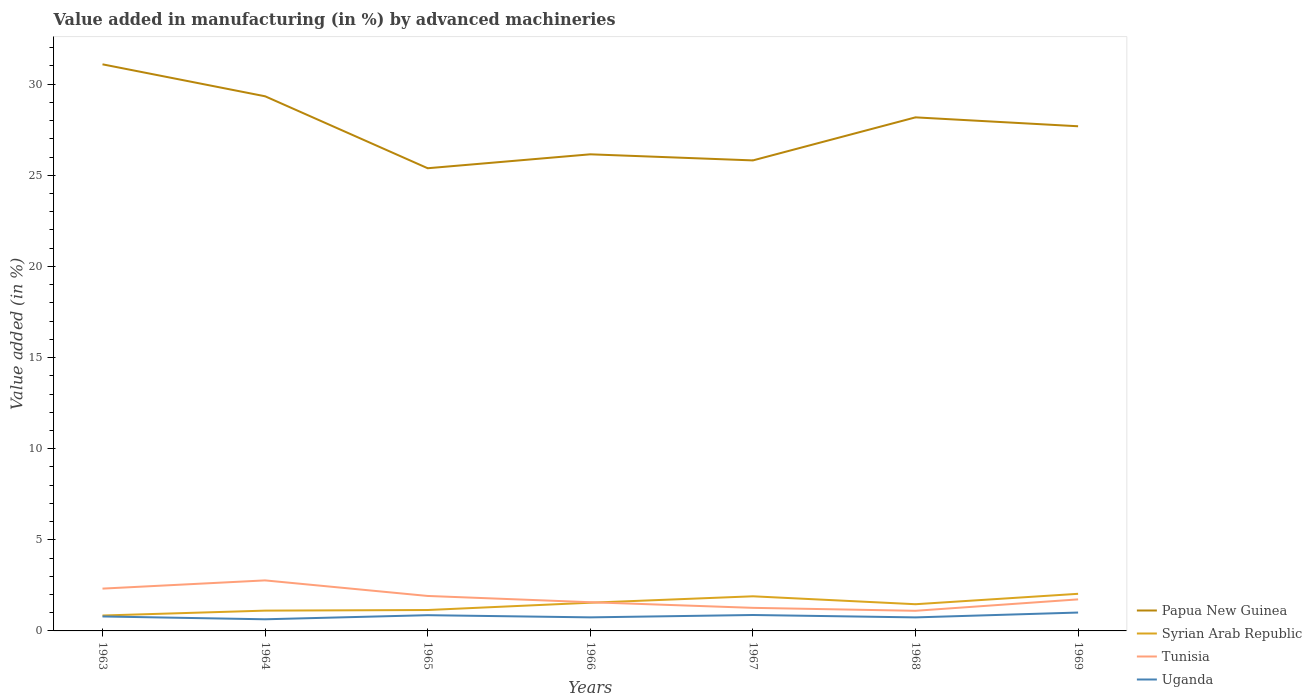How many different coloured lines are there?
Keep it short and to the point. 4. Is the number of lines equal to the number of legend labels?
Provide a succinct answer. Yes. Across all years, what is the maximum percentage of value added in manufacturing by advanced machineries in Uganda?
Keep it short and to the point. 0.64. In which year was the percentage of value added in manufacturing by advanced machineries in Uganda maximum?
Give a very brief answer. 1964. What is the total percentage of value added in manufacturing by advanced machineries in Papua New Guinea in the graph?
Keep it short and to the point. -1.54. What is the difference between the highest and the second highest percentage of value added in manufacturing by advanced machineries in Syrian Arab Republic?
Make the answer very short. 1.19. Is the percentage of value added in manufacturing by advanced machineries in Tunisia strictly greater than the percentage of value added in manufacturing by advanced machineries in Uganda over the years?
Offer a very short reply. No. How many years are there in the graph?
Keep it short and to the point. 7. What is the difference between two consecutive major ticks on the Y-axis?
Ensure brevity in your answer.  5. Does the graph contain any zero values?
Ensure brevity in your answer.  No. How are the legend labels stacked?
Ensure brevity in your answer.  Vertical. What is the title of the graph?
Ensure brevity in your answer.  Value added in manufacturing (in %) by advanced machineries. What is the label or title of the Y-axis?
Provide a succinct answer. Value added (in %). What is the Value added (in %) in Papua New Guinea in 1963?
Offer a very short reply. 31.09. What is the Value added (in %) of Syrian Arab Republic in 1963?
Give a very brief answer. 0.85. What is the Value added (in %) in Tunisia in 1963?
Make the answer very short. 2.32. What is the Value added (in %) of Uganda in 1963?
Offer a very short reply. 0.79. What is the Value added (in %) of Papua New Guinea in 1964?
Provide a succinct answer. 29.34. What is the Value added (in %) in Syrian Arab Republic in 1964?
Give a very brief answer. 1.11. What is the Value added (in %) in Tunisia in 1964?
Your answer should be very brief. 2.77. What is the Value added (in %) of Uganda in 1964?
Offer a very short reply. 0.64. What is the Value added (in %) in Papua New Guinea in 1965?
Provide a succinct answer. 25.39. What is the Value added (in %) of Syrian Arab Republic in 1965?
Ensure brevity in your answer.  1.15. What is the Value added (in %) of Tunisia in 1965?
Your answer should be very brief. 1.92. What is the Value added (in %) of Uganda in 1965?
Your response must be concise. 0.86. What is the Value added (in %) of Papua New Guinea in 1966?
Your response must be concise. 26.15. What is the Value added (in %) in Syrian Arab Republic in 1966?
Your answer should be very brief. 1.55. What is the Value added (in %) of Tunisia in 1966?
Your answer should be very brief. 1.58. What is the Value added (in %) in Uganda in 1966?
Your answer should be very brief. 0.74. What is the Value added (in %) in Papua New Guinea in 1967?
Provide a succinct answer. 25.82. What is the Value added (in %) of Syrian Arab Republic in 1967?
Offer a very short reply. 1.9. What is the Value added (in %) in Tunisia in 1967?
Offer a terse response. 1.27. What is the Value added (in %) of Uganda in 1967?
Make the answer very short. 0.87. What is the Value added (in %) in Papua New Guinea in 1968?
Your response must be concise. 28.18. What is the Value added (in %) of Syrian Arab Republic in 1968?
Provide a succinct answer. 1.46. What is the Value added (in %) in Tunisia in 1968?
Provide a succinct answer. 1.1. What is the Value added (in %) in Uganda in 1968?
Give a very brief answer. 0.74. What is the Value added (in %) in Papua New Guinea in 1969?
Offer a very short reply. 27.69. What is the Value added (in %) in Syrian Arab Republic in 1969?
Make the answer very short. 2.04. What is the Value added (in %) of Tunisia in 1969?
Your answer should be compact. 1.73. What is the Value added (in %) of Uganda in 1969?
Offer a terse response. 1.01. Across all years, what is the maximum Value added (in %) in Papua New Guinea?
Provide a short and direct response. 31.09. Across all years, what is the maximum Value added (in %) of Syrian Arab Republic?
Offer a very short reply. 2.04. Across all years, what is the maximum Value added (in %) in Tunisia?
Your response must be concise. 2.77. Across all years, what is the maximum Value added (in %) of Uganda?
Your answer should be compact. 1.01. Across all years, what is the minimum Value added (in %) in Papua New Guinea?
Your response must be concise. 25.39. Across all years, what is the minimum Value added (in %) of Syrian Arab Republic?
Provide a short and direct response. 0.85. Across all years, what is the minimum Value added (in %) of Tunisia?
Make the answer very short. 1.1. Across all years, what is the minimum Value added (in %) in Uganda?
Offer a terse response. 0.64. What is the total Value added (in %) in Papua New Guinea in the graph?
Your answer should be compact. 193.66. What is the total Value added (in %) in Syrian Arab Republic in the graph?
Offer a very short reply. 10.06. What is the total Value added (in %) of Tunisia in the graph?
Ensure brevity in your answer.  12.69. What is the total Value added (in %) of Uganda in the graph?
Provide a succinct answer. 5.66. What is the difference between the Value added (in %) of Papua New Guinea in 1963 and that in 1964?
Offer a terse response. 1.75. What is the difference between the Value added (in %) of Syrian Arab Republic in 1963 and that in 1964?
Keep it short and to the point. -0.27. What is the difference between the Value added (in %) in Tunisia in 1963 and that in 1964?
Give a very brief answer. -0.45. What is the difference between the Value added (in %) of Uganda in 1963 and that in 1964?
Offer a terse response. 0.15. What is the difference between the Value added (in %) of Papua New Guinea in 1963 and that in 1965?
Ensure brevity in your answer.  5.7. What is the difference between the Value added (in %) in Syrian Arab Republic in 1963 and that in 1965?
Your answer should be compact. -0.3. What is the difference between the Value added (in %) of Tunisia in 1963 and that in 1965?
Your answer should be compact. 0.4. What is the difference between the Value added (in %) of Uganda in 1963 and that in 1965?
Your response must be concise. -0.07. What is the difference between the Value added (in %) in Papua New Guinea in 1963 and that in 1966?
Provide a short and direct response. 4.94. What is the difference between the Value added (in %) in Syrian Arab Republic in 1963 and that in 1966?
Your answer should be compact. -0.7. What is the difference between the Value added (in %) of Tunisia in 1963 and that in 1966?
Your answer should be very brief. 0.75. What is the difference between the Value added (in %) of Uganda in 1963 and that in 1966?
Keep it short and to the point. 0.05. What is the difference between the Value added (in %) in Papua New Guinea in 1963 and that in 1967?
Provide a succinct answer. 5.27. What is the difference between the Value added (in %) in Syrian Arab Republic in 1963 and that in 1967?
Ensure brevity in your answer.  -1.05. What is the difference between the Value added (in %) in Tunisia in 1963 and that in 1967?
Offer a terse response. 1.06. What is the difference between the Value added (in %) of Uganda in 1963 and that in 1967?
Your answer should be very brief. -0.08. What is the difference between the Value added (in %) in Papua New Guinea in 1963 and that in 1968?
Provide a short and direct response. 2.91. What is the difference between the Value added (in %) in Syrian Arab Republic in 1963 and that in 1968?
Your response must be concise. -0.62. What is the difference between the Value added (in %) of Tunisia in 1963 and that in 1968?
Your response must be concise. 1.22. What is the difference between the Value added (in %) of Uganda in 1963 and that in 1968?
Offer a terse response. 0.05. What is the difference between the Value added (in %) of Papua New Guinea in 1963 and that in 1969?
Offer a very short reply. 3.4. What is the difference between the Value added (in %) of Syrian Arab Republic in 1963 and that in 1969?
Provide a succinct answer. -1.19. What is the difference between the Value added (in %) of Tunisia in 1963 and that in 1969?
Your response must be concise. 0.59. What is the difference between the Value added (in %) of Uganda in 1963 and that in 1969?
Your response must be concise. -0.21. What is the difference between the Value added (in %) of Papua New Guinea in 1964 and that in 1965?
Your answer should be compact. 3.95. What is the difference between the Value added (in %) in Syrian Arab Republic in 1964 and that in 1965?
Provide a succinct answer. -0.03. What is the difference between the Value added (in %) in Tunisia in 1964 and that in 1965?
Your answer should be very brief. 0.85. What is the difference between the Value added (in %) in Uganda in 1964 and that in 1965?
Give a very brief answer. -0.22. What is the difference between the Value added (in %) of Papua New Guinea in 1964 and that in 1966?
Offer a terse response. 3.18. What is the difference between the Value added (in %) in Syrian Arab Republic in 1964 and that in 1966?
Offer a very short reply. -0.43. What is the difference between the Value added (in %) of Tunisia in 1964 and that in 1966?
Give a very brief answer. 1.2. What is the difference between the Value added (in %) in Uganda in 1964 and that in 1966?
Give a very brief answer. -0.11. What is the difference between the Value added (in %) of Papua New Guinea in 1964 and that in 1967?
Offer a terse response. 3.52. What is the difference between the Value added (in %) in Syrian Arab Republic in 1964 and that in 1967?
Offer a terse response. -0.79. What is the difference between the Value added (in %) in Tunisia in 1964 and that in 1967?
Give a very brief answer. 1.51. What is the difference between the Value added (in %) of Uganda in 1964 and that in 1967?
Keep it short and to the point. -0.23. What is the difference between the Value added (in %) in Papua New Guinea in 1964 and that in 1968?
Keep it short and to the point. 1.16. What is the difference between the Value added (in %) of Syrian Arab Republic in 1964 and that in 1968?
Provide a succinct answer. -0.35. What is the difference between the Value added (in %) of Tunisia in 1964 and that in 1968?
Give a very brief answer. 1.67. What is the difference between the Value added (in %) in Uganda in 1964 and that in 1968?
Offer a terse response. -0.1. What is the difference between the Value added (in %) of Papua New Guinea in 1964 and that in 1969?
Give a very brief answer. 1.65. What is the difference between the Value added (in %) in Syrian Arab Republic in 1964 and that in 1969?
Give a very brief answer. -0.92. What is the difference between the Value added (in %) of Tunisia in 1964 and that in 1969?
Offer a very short reply. 1.04. What is the difference between the Value added (in %) in Uganda in 1964 and that in 1969?
Ensure brevity in your answer.  -0.37. What is the difference between the Value added (in %) in Papua New Guinea in 1965 and that in 1966?
Ensure brevity in your answer.  -0.76. What is the difference between the Value added (in %) in Syrian Arab Republic in 1965 and that in 1966?
Offer a terse response. -0.4. What is the difference between the Value added (in %) of Tunisia in 1965 and that in 1966?
Make the answer very short. 0.34. What is the difference between the Value added (in %) in Uganda in 1965 and that in 1966?
Give a very brief answer. 0.12. What is the difference between the Value added (in %) of Papua New Guinea in 1965 and that in 1967?
Keep it short and to the point. -0.43. What is the difference between the Value added (in %) of Syrian Arab Republic in 1965 and that in 1967?
Make the answer very short. -0.75. What is the difference between the Value added (in %) of Tunisia in 1965 and that in 1967?
Your answer should be very brief. 0.65. What is the difference between the Value added (in %) in Uganda in 1965 and that in 1967?
Provide a short and direct response. -0.01. What is the difference between the Value added (in %) in Papua New Guinea in 1965 and that in 1968?
Make the answer very short. -2.79. What is the difference between the Value added (in %) of Syrian Arab Republic in 1965 and that in 1968?
Keep it short and to the point. -0.32. What is the difference between the Value added (in %) in Tunisia in 1965 and that in 1968?
Give a very brief answer. 0.81. What is the difference between the Value added (in %) of Uganda in 1965 and that in 1968?
Your answer should be very brief. 0.12. What is the difference between the Value added (in %) of Papua New Guinea in 1965 and that in 1969?
Your answer should be compact. -2.3. What is the difference between the Value added (in %) in Syrian Arab Republic in 1965 and that in 1969?
Make the answer very short. -0.89. What is the difference between the Value added (in %) of Tunisia in 1965 and that in 1969?
Offer a very short reply. 0.19. What is the difference between the Value added (in %) of Uganda in 1965 and that in 1969?
Provide a short and direct response. -0.14. What is the difference between the Value added (in %) of Papua New Guinea in 1966 and that in 1967?
Your response must be concise. 0.33. What is the difference between the Value added (in %) in Syrian Arab Republic in 1966 and that in 1967?
Offer a terse response. -0.35. What is the difference between the Value added (in %) of Tunisia in 1966 and that in 1967?
Your answer should be very brief. 0.31. What is the difference between the Value added (in %) in Uganda in 1966 and that in 1967?
Give a very brief answer. -0.13. What is the difference between the Value added (in %) in Papua New Guinea in 1966 and that in 1968?
Offer a very short reply. -2.03. What is the difference between the Value added (in %) in Syrian Arab Republic in 1966 and that in 1968?
Offer a very short reply. 0.08. What is the difference between the Value added (in %) in Tunisia in 1966 and that in 1968?
Your response must be concise. 0.47. What is the difference between the Value added (in %) in Uganda in 1966 and that in 1968?
Offer a terse response. 0. What is the difference between the Value added (in %) in Papua New Guinea in 1966 and that in 1969?
Offer a terse response. -1.54. What is the difference between the Value added (in %) of Syrian Arab Republic in 1966 and that in 1969?
Provide a succinct answer. -0.49. What is the difference between the Value added (in %) in Tunisia in 1966 and that in 1969?
Ensure brevity in your answer.  -0.16. What is the difference between the Value added (in %) of Uganda in 1966 and that in 1969?
Keep it short and to the point. -0.26. What is the difference between the Value added (in %) in Papua New Guinea in 1967 and that in 1968?
Your response must be concise. -2.36. What is the difference between the Value added (in %) of Syrian Arab Republic in 1967 and that in 1968?
Provide a short and direct response. 0.43. What is the difference between the Value added (in %) in Tunisia in 1967 and that in 1968?
Provide a short and direct response. 0.16. What is the difference between the Value added (in %) in Uganda in 1967 and that in 1968?
Your answer should be compact. 0.13. What is the difference between the Value added (in %) of Papua New Guinea in 1967 and that in 1969?
Your answer should be very brief. -1.87. What is the difference between the Value added (in %) in Syrian Arab Republic in 1967 and that in 1969?
Your response must be concise. -0.14. What is the difference between the Value added (in %) of Tunisia in 1967 and that in 1969?
Your answer should be compact. -0.47. What is the difference between the Value added (in %) of Uganda in 1967 and that in 1969?
Ensure brevity in your answer.  -0.13. What is the difference between the Value added (in %) in Papua New Guinea in 1968 and that in 1969?
Keep it short and to the point. 0.49. What is the difference between the Value added (in %) in Syrian Arab Republic in 1968 and that in 1969?
Your response must be concise. -0.57. What is the difference between the Value added (in %) in Tunisia in 1968 and that in 1969?
Your answer should be very brief. -0.63. What is the difference between the Value added (in %) in Uganda in 1968 and that in 1969?
Provide a succinct answer. -0.27. What is the difference between the Value added (in %) of Papua New Guinea in 1963 and the Value added (in %) of Syrian Arab Republic in 1964?
Make the answer very short. 29.98. What is the difference between the Value added (in %) of Papua New Guinea in 1963 and the Value added (in %) of Tunisia in 1964?
Provide a succinct answer. 28.32. What is the difference between the Value added (in %) in Papua New Guinea in 1963 and the Value added (in %) in Uganda in 1964?
Keep it short and to the point. 30.45. What is the difference between the Value added (in %) in Syrian Arab Republic in 1963 and the Value added (in %) in Tunisia in 1964?
Your response must be concise. -1.93. What is the difference between the Value added (in %) of Syrian Arab Republic in 1963 and the Value added (in %) of Uganda in 1964?
Provide a short and direct response. 0.21. What is the difference between the Value added (in %) in Tunisia in 1963 and the Value added (in %) in Uganda in 1964?
Make the answer very short. 1.68. What is the difference between the Value added (in %) in Papua New Guinea in 1963 and the Value added (in %) in Syrian Arab Republic in 1965?
Provide a short and direct response. 29.94. What is the difference between the Value added (in %) in Papua New Guinea in 1963 and the Value added (in %) in Tunisia in 1965?
Keep it short and to the point. 29.17. What is the difference between the Value added (in %) of Papua New Guinea in 1963 and the Value added (in %) of Uganda in 1965?
Provide a succinct answer. 30.23. What is the difference between the Value added (in %) of Syrian Arab Republic in 1963 and the Value added (in %) of Tunisia in 1965?
Make the answer very short. -1.07. What is the difference between the Value added (in %) in Syrian Arab Republic in 1963 and the Value added (in %) in Uganda in 1965?
Your answer should be very brief. -0.02. What is the difference between the Value added (in %) of Tunisia in 1963 and the Value added (in %) of Uganda in 1965?
Offer a very short reply. 1.46. What is the difference between the Value added (in %) of Papua New Guinea in 1963 and the Value added (in %) of Syrian Arab Republic in 1966?
Offer a very short reply. 29.54. What is the difference between the Value added (in %) of Papua New Guinea in 1963 and the Value added (in %) of Tunisia in 1966?
Ensure brevity in your answer.  29.52. What is the difference between the Value added (in %) in Papua New Guinea in 1963 and the Value added (in %) in Uganda in 1966?
Your answer should be very brief. 30.35. What is the difference between the Value added (in %) in Syrian Arab Republic in 1963 and the Value added (in %) in Tunisia in 1966?
Ensure brevity in your answer.  -0.73. What is the difference between the Value added (in %) in Syrian Arab Republic in 1963 and the Value added (in %) in Uganda in 1966?
Ensure brevity in your answer.  0.1. What is the difference between the Value added (in %) of Tunisia in 1963 and the Value added (in %) of Uganda in 1966?
Your answer should be compact. 1.58. What is the difference between the Value added (in %) in Papua New Guinea in 1963 and the Value added (in %) in Syrian Arab Republic in 1967?
Keep it short and to the point. 29.19. What is the difference between the Value added (in %) in Papua New Guinea in 1963 and the Value added (in %) in Tunisia in 1967?
Offer a very short reply. 29.82. What is the difference between the Value added (in %) of Papua New Guinea in 1963 and the Value added (in %) of Uganda in 1967?
Your answer should be very brief. 30.22. What is the difference between the Value added (in %) in Syrian Arab Republic in 1963 and the Value added (in %) in Tunisia in 1967?
Keep it short and to the point. -0.42. What is the difference between the Value added (in %) of Syrian Arab Republic in 1963 and the Value added (in %) of Uganda in 1967?
Your answer should be compact. -0.03. What is the difference between the Value added (in %) of Tunisia in 1963 and the Value added (in %) of Uganda in 1967?
Your response must be concise. 1.45. What is the difference between the Value added (in %) in Papua New Guinea in 1963 and the Value added (in %) in Syrian Arab Republic in 1968?
Provide a succinct answer. 29.63. What is the difference between the Value added (in %) in Papua New Guinea in 1963 and the Value added (in %) in Tunisia in 1968?
Give a very brief answer. 29.99. What is the difference between the Value added (in %) in Papua New Guinea in 1963 and the Value added (in %) in Uganda in 1968?
Your answer should be very brief. 30.35. What is the difference between the Value added (in %) of Syrian Arab Republic in 1963 and the Value added (in %) of Tunisia in 1968?
Your answer should be compact. -0.26. What is the difference between the Value added (in %) of Syrian Arab Republic in 1963 and the Value added (in %) of Uganda in 1968?
Provide a succinct answer. 0.1. What is the difference between the Value added (in %) in Tunisia in 1963 and the Value added (in %) in Uganda in 1968?
Offer a terse response. 1.58. What is the difference between the Value added (in %) of Papua New Guinea in 1963 and the Value added (in %) of Syrian Arab Republic in 1969?
Give a very brief answer. 29.05. What is the difference between the Value added (in %) in Papua New Guinea in 1963 and the Value added (in %) in Tunisia in 1969?
Ensure brevity in your answer.  29.36. What is the difference between the Value added (in %) of Papua New Guinea in 1963 and the Value added (in %) of Uganda in 1969?
Offer a terse response. 30.08. What is the difference between the Value added (in %) in Syrian Arab Republic in 1963 and the Value added (in %) in Tunisia in 1969?
Your answer should be very brief. -0.89. What is the difference between the Value added (in %) in Syrian Arab Republic in 1963 and the Value added (in %) in Uganda in 1969?
Provide a succinct answer. -0.16. What is the difference between the Value added (in %) of Tunisia in 1963 and the Value added (in %) of Uganda in 1969?
Your answer should be compact. 1.31. What is the difference between the Value added (in %) of Papua New Guinea in 1964 and the Value added (in %) of Syrian Arab Republic in 1965?
Give a very brief answer. 28.19. What is the difference between the Value added (in %) of Papua New Guinea in 1964 and the Value added (in %) of Tunisia in 1965?
Provide a succinct answer. 27.42. What is the difference between the Value added (in %) in Papua New Guinea in 1964 and the Value added (in %) in Uganda in 1965?
Provide a short and direct response. 28.47. What is the difference between the Value added (in %) of Syrian Arab Republic in 1964 and the Value added (in %) of Tunisia in 1965?
Your answer should be compact. -0.8. What is the difference between the Value added (in %) in Syrian Arab Republic in 1964 and the Value added (in %) in Uganda in 1965?
Offer a terse response. 0.25. What is the difference between the Value added (in %) in Tunisia in 1964 and the Value added (in %) in Uganda in 1965?
Keep it short and to the point. 1.91. What is the difference between the Value added (in %) of Papua New Guinea in 1964 and the Value added (in %) of Syrian Arab Republic in 1966?
Ensure brevity in your answer.  27.79. What is the difference between the Value added (in %) in Papua New Guinea in 1964 and the Value added (in %) in Tunisia in 1966?
Your answer should be very brief. 27.76. What is the difference between the Value added (in %) in Papua New Guinea in 1964 and the Value added (in %) in Uganda in 1966?
Offer a very short reply. 28.59. What is the difference between the Value added (in %) in Syrian Arab Republic in 1964 and the Value added (in %) in Tunisia in 1966?
Your answer should be compact. -0.46. What is the difference between the Value added (in %) in Syrian Arab Republic in 1964 and the Value added (in %) in Uganda in 1966?
Offer a terse response. 0.37. What is the difference between the Value added (in %) in Tunisia in 1964 and the Value added (in %) in Uganda in 1966?
Your answer should be compact. 2.03. What is the difference between the Value added (in %) in Papua New Guinea in 1964 and the Value added (in %) in Syrian Arab Republic in 1967?
Provide a short and direct response. 27.44. What is the difference between the Value added (in %) in Papua New Guinea in 1964 and the Value added (in %) in Tunisia in 1967?
Your answer should be very brief. 28.07. What is the difference between the Value added (in %) of Papua New Guinea in 1964 and the Value added (in %) of Uganda in 1967?
Make the answer very short. 28.46. What is the difference between the Value added (in %) in Syrian Arab Republic in 1964 and the Value added (in %) in Tunisia in 1967?
Keep it short and to the point. -0.15. What is the difference between the Value added (in %) in Syrian Arab Republic in 1964 and the Value added (in %) in Uganda in 1967?
Offer a very short reply. 0.24. What is the difference between the Value added (in %) of Tunisia in 1964 and the Value added (in %) of Uganda in 1967?
Your response must be concise. 1.9. What is the difference between the Value added (in %) in Papua New Guinea in 1964 and the Value added (in %) in Syrian Arab Republic in 1968?
Offer a terse response. 27.87. What is the difference between the Value added (in %) of Papua New Guinea in 1964 and the Value added (in %) of Tunisia in 1968?
Offer a very short reply. 28.23. What is the difference between the Value added (in %) in Papua New Guinea in 1964 and the Value added (in %) in Uganda in 1968?
Keep it short and to the point. 28.6. What is the difference between the Value added (in %) in Syrian Arab Republic in 1964 and the Value added (in %) in Tunisia in 1968?
Offer a terse response. 0.01. What is the difference between the Value added (in %) in Syrian Arab Republic in 1964 and the Value added (in %) in Uganda in 1968?
Make the answer very short. 0.37. What is the difference between the Value added (in %) of Tunisia in 1964 and the Value added (in %) of Uganda in 1968?
Give a very brief answer. 2.03. What is the difference between the Value added (in %) of Papua New Guinea in 1964 and the Value added (in %) of Syrian Arab Republic in 1969?
Ensure brevity in your answer.  27.3. What is the difference between the Value added (in %) of Papua New Guinea in 1964 and the Value added (in %) of Tunisia in 1969?
Ensure brevity in your answer.  27.61. What is the difference between the Value added (in %) in Papua New Guinea in 1964 and the Value added (in %) in Uganda in 1969?
Your answer should be compact. 28.33. What is the difference between the Value added (in %) of Syrian Arab Republic in 1964 and the Value added (in %) of Tunisia in 1969?
Your response must be concise. -0.62. What is the difference between the Value added (in %) in Syrian Arab Republic in 1964 and the Value added (in %) in Uganda in 1969?
Keep it short and to the point. 0.11. What is the difference between the Value added (in %) of Tunisia in 1964 and the Value added (in %) of Uganda in 1969?
Your answer should be compact. 1.76. What is the difference between the Value added (in %) in Papua New Guinea in 1965 and the Value added (in %) in Syrian Arab Republic in 1966?
Your response must be concise. 23.84. What is the difference between the Value added (in %) of Papua New Guinea in 1965 and the Value added (in %) of Tunisia in 1966?
Offer a terse response. 23.81. What is the difference between the Value added (in %) of Papua New Guinea in 1965 and the Value added (in %) of Uganda in 1966?
Offer a terse response. 24.64. What is the difference between the Value added (in %) of Syrian Arab Republic in 1965 and the Value added (in %) of Tunisia in 1966?
Give a very brief answer. -0.43. What is the difference between the Value added (in %) in Syrian Arab Republic in 1965 and the Value added (in %) in Uganda in 1966?
Your answer should be compact. 0.4. What is the difference between the Value added (in %) of Tunisia in 1965 and the Value added (in %) of Uganda in 1966?
Provide a succinct answer. 1.17. What is the difference between the Value added (in %) of Papua New Guinea in 1965 and the Value added (in %) of Syrian Arab Republic in 1967?
Provide a short and direct response. 23.49. What is the difference between the Value added (in %) of Papua New Guinea in 1965 and the Value added (in %) of Tunisia in 1967?
Your answer should be very brief. 24.12. What is the difference between the Value added (in %) in Papua New Guinea in 1965 and the Value added (in %) in Uganda in 1967?
Provide a succinct answer. 24.52. What is the difference between the Value added (in %) in Syrian Arab Republic in 1965 and the Value added (in %) in Tunisia in 1967?
Your answer should be very brief. -0.12. What is the difference between the Value added (in %) in Syrian Arab Republic in 1965 and the Value added (in %) in Uganda in 1967?
Make the answer very short. 0.27. What is the difference between the Value added (in %) of Tunisia in 1965 and the Value added (in %) of Uganda in 1967?
Your answer should be compact. 1.04. What is the difference between the Value added (in %) in Papua New Guinea in 1965 and the Value added (in %) in Syrian Arab Republic in 1968?
Your answer should be compact. 23.92. What is the difference between the Value added (in %) of Papua New Guinea in 1965 and the Value added (in %) of Tunisia in 1968?
Provide a succinct answer. 24.28. What is the difference between the Value added (in %) in Papua New Guinea in 1965 and the Value added (in %) in Uganda in 1968?
Your answer should be very brief. 24.65. What is the difference between the Value added (in %) of Syrian Arab Republic in 1965 and the Value added (in %) of Tunisia in 1968?
Provide a short and direct response. 0.04. What is the difference between the Value added (in %) of Syrian Arab Republic in 1965 and the Value added (in %) of Uganda in 1968?
Keep it short and to the point. 0.41. What is the difference between the Value added (in %) in Tunisia in 1965 and the Value added (in %) in Uganda in 1968?
Provide a succinct answer. 1.18. What is the difference between the Value added (in %) of Papua New Guinea in 1965 and the Value added (in %) of Syrian Arab Republic in 1969?
Give a very brief answer. 23.35. What is the difference between the Value added (in %) of Papua New Guinea in 1965 and the Value added (in %) of Tunisia in 1969?
Offer a terse response. 23.66. What is the difference between the Value added (in %) in Papua New Guinea in 1965 and the Value added (in %) in Uganda in 1969?
Offer a very short reply. 24.38. What is the difference between the Value added (in %) in Syrian Arab Republic in 1965 and the Value added (in %) in Tunisia in 1969?
Your answer should be very brief. -0.58. What is the difference between the Value added (in %) in Syrian Arab Republic in 1965 and the Value added (in %) in Uganda in 1969?
Ensure brevity in your answer.  0.14. What is the difference between the Value added (in %) of Tunisia in 1965 and the Value added (in %) of Uganda in 1969?
Provide a short and direct response. 0.91. What is the difference between the Value added (in %) of Papua New Guinea in 1966 and the Value added (in %) of Syrian Arab Republic in 1967?
Your answer should be compact. 24.25. What is the difference between the Value added (in %) in Papua New Guinea in 1966 and the Value added (in %) in Tunisia in 1967?
Give a very brief answer. 24.89. What is the difference between the Value added (in %) in Papua New Guinea in 1966 and the Value added (in %) in Uganda in 1967?
Provide a short and direct response. 25.28. What is the difference between the Value added (in %) in Syrian Arab Republic in 1966 and the Value added (in %) in Tunisia in 1967?
Your answer should be very brief. 0.28. What is the difference between the Value added (in %) of Syrian Arab Republic in 1966 and the Value added (in %) of Uganda in 1967?
Offer a terse response. 0.67. What is the difference between the Value added (in %) in Tunisia in 1966 and the Value added (in %) in Uganda in 1967?
Provide a short and direct response. 0.7. What is the difference between the Value added (in %) of Papua New Guinea in 1966 and the Value added (in %) of Syrian Arab Republic in 1968?
Provide a succinct answer. 24.69. What is the difference between the Value added (in %) of Papua New Guinea in 1966 and the Value added (in %) of Tunisia in 1968?
Ensure brevity in your answer.  25.05. What is the difference between the Value added (in %) in Papua New Guinea in 1966 and the Value added (in %) in Uganda in 1968?
Provide a short and direct response. 25.41. What is the difference between the Value added (in %) in Syrian Arab Republic in 1966 and the Value added (in %) in Tunisia in 1968?
Your answer should be compact. 0.44. What is the difference between the Value added (in %) of Syrian Arab Republic in 1966 and the Value added (in %) of Uganda in 1968?
Offer a terse response. 0.81. What is the difference between the Value added (in %) in Papua New Guinea in 1966 and the Value added (in %) in Syrian Arab Republic in 1969?
Provide a succinct answer. 24.12. What is the difference between the Value added (in %) in Papua New Guinea in 1966 and the Value added (in %) in Tunisia in 1969?
Ensure brevity in your answer.  24.42. What is the difference between the Value added (in %) of Papua New Guinea in 1966 and the Value added (in %) of Uganda in 1969?
Give a very brief answer. 25.14. What is the difference between the Value added (in %) of Syrian Arab Republic in 1966 and the Value added (in %) of Tunisia in 1969?
Keep it short and to the point. -0.18. What is the difference between the Value added (in %) of Syrian Arab Republic in 1966 and the Value added (in %) of Uganda in 1969?
Provide a short and direct response. 0.54. What is the difference between the Value added (in %) in Tunisia in 1966 and the Value added (in %) in Uganda in 1969?
Ensure brevity in your answer.  0.57. What is the difference between the Value added (in %) of Papua New Guinea in 1967 and the Value added (in %) of Syrian Arab Republic in 1968?
Provide a succinct answer. 24.35. What is the difference between the Value added (in %) of Papua New Guinea in 1967 and the Value added (in %) of Tunisia in 1968?
Offer a very short reply. 24.71. What is the difference between the Value added (in %) in Papua New Guinea in 1967 and the Value added (in %) in Uganda in 1968?
Provide a short and direct response. 25.08. What is the difference between the Value added (in %) in Syrian Arab Republic in 1967 and the Value added (in %) in Tunisia in 1968?
Ensure brevity in your answer.  0.8. What is the difference between the Value added (in %) of Syrian Arab Republic in 1967 and the Value added (in %) of Uganda in 1968?
Your response must be concise. 1.16. What is the difference between the Value added (in %) of Tunisia in 1967 and the Value added (in %) of Uganda in 1968?
Provide a succinct answer. 0.52. What is the difference between the Value added (in %) in Papua New Guinea in 1967 and the Value added (in %) in Syrian Arab Republic in 1969?
Your answer should be very brief. 23.78. What is the difference between the Value added (in %) of Papua New Guinea in 1967 and the Value added (in %) of Tunisia in 1969?
Offer a terse response. 24.09. What is the difference between the Value added (in %) of Papua New Guinea in 1967 and the Value added (in %) of Uganda in 1969?
Make the answer very short. 24.81. What is the difference between the Value added (in %) in Syrian Arab Republic in 1967 and the Value added (in %) in Tunisia in 1969?
Your response must be concise. 0.17. What is the difference between the Value added (in %) of Syrian Arab Republic in 1967 and the Value added (in %) of Uganda in 1969?
Your answer should be very brief. 0.89. What is the difference between the Value added (in %) of Tunisia in 1967 and the Value added (in %) of Uganda in 1969?
Ensure brevity in your answer.  0.26. What is the difference between the Value added (in %) of Papua New Guinea in 1968 and the Value added (in %) of Syrian Arab Republic in 1969?
Provide a succinct answer. 26.14. What is the difference between the Value added (in %) of Papua New Guinea in 1968 and the Value added (in %) of Tunisia in 1969?
Your response must be concise. 26.45. What is the difference between the Value added (in %) of Papua New Guinea in 1968 and the Value added (in %) of Uganda in 1969?
Make the answer very short. 27.17. What is the difference between the Value added (in %) of Syrian Arab Republic in 1968 and the Value added (in %) of Tunisia in 1969?
Your response must be concise. -0.27. What is the difference between the Value added (in %) in Syrian Arab Republic in 1968 and the Value added (in %) in Uganda in 1969?
Your response must be concise. 0.46. What is the difference between the Value added (in %) in Tunisia in 1968 and the Value added (in %) in Uganda in 1969?
Your answer should be compact. 0.1. What is the average Value added (in %) in Papua New Guinea per year?
Make the answer very short. 27.67. What is the average Value added (in %) of Syrian Arab Republic per year?
Make the answer very short. 1.44. What is the average Value added (in %) of Tunisia per year?
Give a very brief answer. 1.81. What is the average Value added (in %) in Uganda per year?
Offer a terse response. 0.81. In the year 1963, what is the difference between the Value added (in %) in Papua New Guinea and Value added (in %) in Syrian Arab Republic?
Give a very brief answer. 30.25. In the year 1963, what is the difference between the Value added (in %) in Papua New Guinea and Value added (in %) in Tunisia?
Offer a very short reply. 28.77. In the year 1963, what is the difference between the Value added (in %) in Papua New Guinea and Value added (in %) in Uganda?
Offer a very short reply. 30.3. In the year 1963, what is the difference between the Value added (in %) of Syrian Arab Republic and Value added (in %) of Tunisia?
Your answer should be very brief. -1.48. In the year 1963, what is the difference between the Value added (in %) of Syrian Arab Republic and Value added (in %) of Uganda?
Make the answer very short. 0.05. In the year 1963, what is the difference between the Value added (in %) of Tunisia and Value added (in %) of Uganda?
Keep it short and to the point. 1.53. In the year 1964, what is the difference between the Value added (in %) in Papua New Guinea and Value added (in %) in Syrian Arab Republic?
Offer a very short reply. 28.22. In the year 1964, what is the difference between the Value added (in %) of Papua New Guinea and Value added (in %) of Tunisia?
Keep it short and to the point. 26.56. In the year 1964, what is the difference between the Value added (in %) of Papua New Guinea and Value added (in %) of Uganda?
Ensure brevity in your answer.  28.7. In the year 1964, what is the difference between the Value added (in %) in Syrian Arab Republic and Value added (in %) in Tunisia?
Keep it short and to the point. -1.66. In the year 1964, what is the difference between the Value added (in %) of Syrian Arab Republic and Value added (in %) of Uganda?
Give a very brief answer. 0.47. In the year 1964, what is the difference between the Value added (in %) of Tunisia and Value added (in %) of Uganda?
Provide a short and direct response. 2.13. In the year 1965, what is the difference between the Value added (in %) of Papua New Guinea and Value added (in %) of Syrian Arab Republic?
Your response must be concise. 24.24. In the year 1965, what is the difference between the Value added (in %) of Papua New Guinea and Value added (in %) of Tunisia?
Ensure brevity in your answer.  23.47. In the year 1965, what is the difference between the Value added (in %) in Papua New Guinea and Value added (in %) in Uganda?
Make the answer very short. 24.53. In the year 1965, what is the difference between the Value added (in %) in Syrian Arab Republic and Value added (in %) in Tunisia?
Keep it short and to the point. -0.77. In the year 1965, what is the difference between the Value added (in %) of Syrian Arab Republic and Value added (in %) of Uganda?
Give a very brief answer. 0.28. In the year 1965, what is the difference between the Value added (in %) of Tunisia and Value added (in %) of Uganda?
Your answer should be compact. 1.06. In the year 1966, what is the difference between the Value added (in %) in Papua New Guinea and Value added (in %) in Syrian Arab Republic?
Your response must be concise. 24.6. In the year 1966, what is the difference between the Value added (in %) of Papua New Guinea and Value added (in %) of Tunisia?
Provide a short and direct response. 24.58. In the year 1966, what is the difference between the Value added (in %) in Papua New Guinea and Value added (in %) in Uganda?
Your answer should be compact. 25.41. In the year 1966, what is the difference between the Value added (in %) in Syrian Arab Republic and Value added (in %) in Tunisia?
Offer a very short reply. -0.03. In the year 1966, what is the difference between the Value added (in %) in Syrian Arab Republic and Value added (in %) in Uganda?
Your answer should be very brief. 0.8. In the year 1966, what is the difference between the Value added (in %) of Tunisia and Value added (in %) of Uganda?
Give a very brief answer. 0.83. In the year 1967, what is the difference between the Value added (in %) of Papua New Guinea and Value added (in %) of Syrian Arab Republic?
Your answer should be very brief. 23.92. In the year 1967, what is the difference between the Value added (in %) of Papua New Guinea and Value added (in %) of Tunisia?
Give a very brief answer. 24.55. In the year 1967, what is the difference between the Value added (in %) of Papua New Guinea and Value added (in %) of Uganda?
Ensure brevity in your answer.  24.95. In the year 1967, what is the difference between the Value added (in %) in Syrian Arab Republic and Value added (in %) in Tunisia?
Provide a succinct answer. 0.63. In the year 1967, what is the difference between the Value added (in %) of Syrian Arab Republic and Value added (in %) of Uganda?
Offer a terse response. 1.03. In the year 1967, what is the difference between the Value added (in %) in Tunisia and Value added (in %) in Uganda?
Keep it short and to the point. 0.39. In the year 1968, what is the difference between the Value added (in %) of Papua New Guinea and Value added (in %) of Syrian Arab Republic?
Offer a terse response. 26.72. In the year 1968, what is the difference between the Value added (in %) in Papua New Guinea and Value added (in %) in Tunisia?
Offer a very short reply. 27.08. In the year 1968, what is the difference between the Value added (in %) in Papua New Guinea and Value added (in %) in Uganda?
Provide a succinct answer. 27.44. In the year 1968, what is the difference between the Value added (in %) in Syrian Arab Republic and Value added (in %) in Tunisia?
Make the answer very short. 0.36. In the year 1968, what is the difference between the Value added (in %) in Syrian Arab Republic and Value added (in %) in Uganda?
Your response must be concise. 0.72. In the year 1968, what is the difference between the Value added (in %) of Tunisia and Value added (in %) of Uganda?
Ensure brevity in your answer.  0.36. In the year 1969, what is the difference between the Value added (in %) in Papua New Guinea and Value added (in %) in Syrian Arab Republic?
Offer a very short reply. 25.66. In the year 1969, what is the difference between the Value added (in %) in Papua New Guinea and Value added (in %) in Tunisia?
Your answer should be very brief. 25.96. In the year 1969, what is the difference between the Value added (in %) in Papua New Guinea and Value added (in %) in Uganda?
Make the answer very short. 26.68. In the year 1969, what is the difference between the Value added (in %) of Syrian Arab Republic and Value added (in %) of Tunisia?
Provide a short and direct response. 0.31. In the year 1969, what is the difference between the Value added (in %) in Syrian Arab Republic and Value added (in %) in Uganda?
Your answer should be very brief. 1.03. In the year 1969, what is the difference between the Value added (in %) of Tunisia and Value added (in %) of Uganda?
Offer a terse response. 0.72. What is the ratio of the Value added (in %) of Papua New Guinea in 1963 to that in 1964?
Your answer should be compact. 1.06. What is the ratio of the Value added (in %) of Syrian Arab Republic in 1963 to that in 1964?
Keep it short and to the point. 0.76. What is the ratio of the Value added (in %) of Tunisia in 1963 to that in 1964?
Offer a terse response. 0.84. What is the ratio of the Value added (in %) in Uganda in 1963 to that in 1964?
Provide a succinct answer. 1.24. What is the ratio of the Value added (in %) of Papua New Guinea in 1963 to that in 1965?
Provide a succinct answer. 1.22. What is the ratio of the Value added (in %) in Syrian Arab Republic in 1963 to that in 1965?
Give a very brief answer. 0.74. What is the ratio of the Value added (in %) of Tunisia in 1963 to that in 1965?
Offer a very short reply. 1.21. What is the ratio of the Value added (in %) in Uganda in 1963 to that in 1965?
Your response must be concise. 0.92. What is the ratio of the Value added (in %) of Papua New Guinea in 1963 to that in 1966?
Ensure brevity in your answer.  1.19. What is the ratio of the Value added (in %) in Syrian Arab Republic in 1963 to that in 1966?
Your response must be concise. 0.55. What is the ratio of the Value added (in %) of Tunisia in 1963 to that in 1966?
Offer a terse response. 1.47. What is the ratio of the Value added (in %) in Uganda in 1963 to that in 1966?
Provide a short and direct response. 1.07. What is the ratio of the Value added (in %) in Papua New Guinea in 1963 to that in 1967?
Provide a succinct answer. 1.2. What is the ratio of the Value added (in %) of Syrian Arab Republic in 1963 to that in 1967?
Make the answer very short. 0.45. What is the ratio of the Value added (in %) of Tunisia in 1963 to that in 1967?
Ensure brevity in your answer.  1.83. What is the ratio of the Value added (in %) in Uganda in 1963 to that in 1967?
Make the answer very short. 0.91. What is the ratio of the Value added (in %) in Papua New Guinea in 1963 to that in 1968?
Your answer should be compact. 1.1. What is the ratio of the Value added (in %) of Syrian Arab Republic in 1963 to that in 1968?
Your response must be concise. 0.58. What is the ratio of the Value added (in %) of Tunisia in 1963 to that in 1968?
Offer a very short reply. 2.1. What is the ratio of the Value added (in %) in Uganda in 1963 to that in 1968?
Keep it short and to the point. 1.07. What is the ratio of the Value added (in %) of Papua New Guinea in 1963 to that in 1969?
Provide a short and direct response. 1.12. What is the ratio of the Value added (in %) of Syrian Arab Republic in 1963 to that in 1969?
Offer a very short reply. 0.42. What is the ratio of the Value added (in %) of Tunisia in 1963 to that in 1969?
Give a very brief answer. 1.34. What is the ratio of the Value added (in %) in Uganda in 1963 to that in 1969?
Ensure brevity in your answer.  0.79. What is the ratio of the Value added (in %) of Papua New Guinea in 1964 to that in 1965?
Ensure brevity in your answer.  1.16. What is the ratio of the Value added (in %) of Syrian Arab Republic in 1964 to that in 1965?
Provide a succinct answer. 0.97. What is the ratio of the Value added (in %) of Tunisia in 1964 to that in 1965?
Make the answer very short. 1.45. What is the ratio of the Value added (in %) in Uganda in 1964 to that in 1965?
Offer a very short reply. 0.74. What is the ratio of the Value added (in %) of Papua New Guinea in 1964 to that in 1966?
Give a very brief answer. 1.12. What is the ratio of the Value added (in %) of Syrian Arab Republic in 1964 to that in 1966?
Offer a very short reply. 0.72. What is the ratio of the Value added (in %) in Tunisia in 1964 to that in 1966?
Offer a very short reply. 1.76. What is the ratio of the Value added (in %) in Uganda in 1964 to that in 1966?
Provide a short and direct response. 0.86. What is the ratio of the Value added (in %) in Papua New Guinea in 1964 to that in 1967?
Your answer should be very brief. 1.14. What is the ratio of the Value added (in %) in Syrian Arab Republic in 1964 to that in 1967?
Offer a very short reply. 0.59. What is the ratio of the Value added (in %) in Tunisia in 1964 to that in 1967?
Make the answer very short. 2.19. What is the ratio of the Value added (in %) of Uganda in 1964 to that in 1967?
Keep it short and to the point. 0.73. What is the ratio of the Value added (in %) of Papua New Guinea in 1964 to that in 1968?
Offer a terse response. 1.04. What is the ratio of the Value added (in %) in Syrian Arab Republic in 1964 to that in 1968?
Offer a very short reply. 0.76. What is the ratio of the Value added (in %) of Tunisia in 1964 to that in 1968?
Give a very brief answer. 2.51. What is the ratio of the Value added (in %) in Uganda in 1964 to that in 1968?
Keep it short and to the point. 0.86. What is the ratio of the Value added (in %) of Papua New Guinea in 1964 to that in 1969?
Ensure brevity in your answer.  1.06. What is the ratio of the Value added (in %) in Syrian Arab Republic in 1964 to that in 1969?
Your answer should be very brief. 0.55. What is the ratio of the Value added (in %) of Tunisia in 1964 to that in 1969?
Provide a succinct answer. 1.6. What is the ratio of the Value added (in %) of Uganda in 1964 to that in 1969?
Give a very brief answer. 0.63. What is the ratio of the Value added (in %) in Papua New Guinea in 1965 to that in 1966?
Keep it short and to the point. 0.97. What is the ratio of the Value added (in %) of Syrian Arab Republic in 1965 to that in 1966?
Your answer should be compact. 0.74. What is the ratio of the Value added (in %) in Tunisia in 1965 to that in 1966?
Offer a very short reply. 1.22. What is the ratio of the Value added (in %) of Uganda in 1965 to that in 1966?
Provide a short and direct response. 1.16. What is the ratio of the Value added (in %) in Papua New Guinea in 1965 to that in 1967?
Your answer should be very brief. 0.98. What is the ratio of the Value added (in %) in Syrian Arab Republic in 1965 to that in 1967?
Offer a terse response. 0.6. What is the ratio of the Value added (in %) in Tunisia in 1965 to that in 1967?
Ensure brevity in your answer.  1.52. What is the ratio of the Value added (in %) in Uganda in 1965 to that in 1967?
Give a very brief answer. 0.99. What is the ratio of the Value added (in %) of Papua New Guinea in 1965 to that in 1968?
Give a very brief answer. 0.9. What is the ratio of the Value added (in %) of Syrian Arab Republic in 1965 to that in 1968?
Offer a terse response. 0.78. What is the ratio of the Value added (in %) in Tunisia in 1965 to that in 1968?
Your response must be concise. 1.74. What is the ratio of the Value added (in %) in Uganda in 1965 to that in 1968?
Provide a short and direct response. 1.16. What is the ratio of the Value added (in %) in Papua New Guinea in 1965 to that in 1969?
Provide a succinct answer. 0.92. What is the ratio of the Value added (in %) in Syrian Arab Republic in 1965 to that in 1969?
Your response must be concise. 0.56. What is the ratio of the Value added (in %) in Tunisia in 1965 to that in 1969?
Ensure brevity in your answer.  1.11. What is the ratio of the Value added (in %) in Uganda in 1965 to that in 1969?
Your answer should be compact. 0.86. What is the ratio of the Value added (in %) of Papua New Guinea in 1966 to that in 1967?
Offer a terse response. 1.01. What is the ratio of the Value added (in %) in Syrian Arab Republic in 1966 to that in 1967?
Provide a short and direct response. 0.81. What is the ratio of the Value added (in %) of Tunisia in 1966 to that in 1967?
Give a very brief answer. 1.24. What is the ratio of the Value added (in %) in Uganda in 1966 to that in 1967?
Your answer should be compact. 0.85. What is the ratio of the Value added (in %) in Papua New Guinea in 1966 to that in 1968?
Your answer should be very brief. 0.93. What is the ratio of the Value added (in %) in Syrian Arab Republic in 1966 to that in 1968?
Keep it short and to the point. 1.06. What is the ratio of the Value added (in %) of Tunisia in 1966 to that in 1968?
Your answer should be very brief. 1.43. What is the ratio of the Value added (in %) of Uganda in 1966 to that in 1968?
Provide a succinct answer. 1. What is the ratio of the Value added (in %) in Syrian Arab Republic in 1966 to that in 1969?
Offer a very short reply. 0.76. What is the ratio of the Value added (in %) of Tunisia in 1966 to that in 1969?
Provide a short and direct response. 0.91. What is the ratio of the Value added (in %) of Uganda in 1966 to that in 1969?
Keep it short and to the point. 0.74. What is the ratio of the Value added (in %) of Papua New Guinea in 1967 to that in 1968?
Keep it short and to the point. 0.92. What is the ratio of the Value added (in %) of Syrian Arab Republic in 1967 to that in 1968?
Ensure brevity in your answer.  1.3. What is the ratio of the Value added (in %) in Tunisia in 1967 to that in 1968?
Provide a short and direct response. 1.15. What is the ratio of the Value added (in %) in Uganda in 1967 to that in 1968?
Your answer should be compact. 1.18. What is the ratio of the Value added (in %) of Papua New Guinea in 1967 to that in 1969?
Offer a terse response. 0.93. What is the ratio of the Value added (in %) of Syrian Arab Republic in 1967 to that in 1969?
Give a very brief answer. 0.93. What is the ratio of the Value added (in %) of Tunisia in 1967 to that in 1969?
Give a very brief answer. 0.73. What is the ratio of the Value added (in %) in Uganda in 1967 to that in 1969?
Provide a short and direct response. 0.87. What is the ratio of the Value added (in %) of Papua New Guinea in 1968 to that in 1969?
Keep it short and to the point. 1.02. What is the ratio of the Value added (in %) of Syrian Arab Republic in 1968 to that in 1969?
Offer a terse response. 0.72. What is the ratio of the Value added (in %) in Tunisia in 1968 to that in 1969?
Keep it short and to the point. 0.64. What is the ratio of the Value added (in %) in Uganda in 1968 to that in 1969?
Ensure brevity in your answer.  0.74. What is the difference between the highest and the second highest Value added (in %) of Papua New Guinea?
Your answer should be compact. 1.75. What is the difference between the highest and the second highest Value added (in %) of Syrian Arab Republic?
Ensure brevity in your answer.  0.14. What is the difference between the highest and the second highest Value added (in %) of Tunisia?
Keep it short and to the point. 0.45. What is the difference between the highest and the second highest Value added (in %) in Uganda?
Give a very brief answer. 0.13. What is the difference between the highest and the lowest Value added (in %) of Papua New Guinea?
Your answer should be very brief. 5.7. What is the difference between the highest and the lowest Value added (in %) in Syrian Arab Republic?
Your answer should be compact. 1.19. What is the difference between the highest and the lowest Value added (in %) of Tunisia?
Provide a succinct answer. 1.67. What is the difference between the highest and the lowest Value added (in %) of Uganda?
Your answer should be very brief. 0.37. 